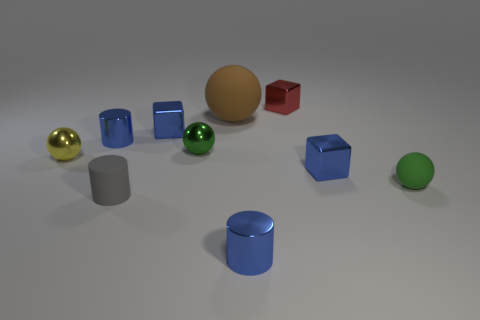Does the thing behind the big brown rubber sphere have the same material as the brown thing on the right side of the small gray matte cylinder?
Your response must be concise. No. Are there any other small balls that have the same color as the tiny rubber ball?
Make the answer very short. Yes. There is a rubber cylinder that is the same size as the green matte thing; what is its color?
Keep it short and to the point. Gray. There is a small shiny sphere that is on the right side of the gray object; is its color the same as the small rubber ball?
Your answer should be very brief. Yes. Is there a brown ball made of the same material as the small red thing?
Ensure brevity in your answer.  No. Are there fewer yellow shiny balls that are behind the brown ball than matte spheres?
Provide a succinct answer. Yes. Do the rubber ball on the right side of the red object and the gray rubber cylinder have the same size?
Provide a succinct answer. Yes. What number of small metal things are the same shape as the gray rubber thing?
Your answer should be compact. 2. The brown thing that is the same material as the tiny gray cylinder is what size?
Offer a terse response. Large. Are there an equal number of large objects in front of the tiny gray thing and tiny gray cylinders?
Your answer should be very brief. No. 